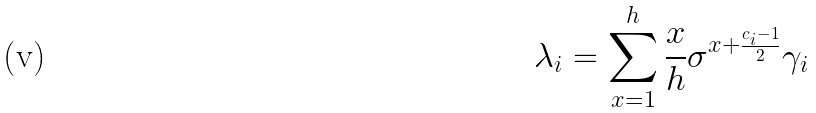Convert formula to latex. <formula><loc_0><loc_0><loc_500><loc_500>\lambda _ { i } = \sum _ { x = 1 } ^ { h } \frac { x } { h } \sigma ^ { x + \frac { c _ { i } - 1 } { 2 } } \gamma _ { i }</formula> 